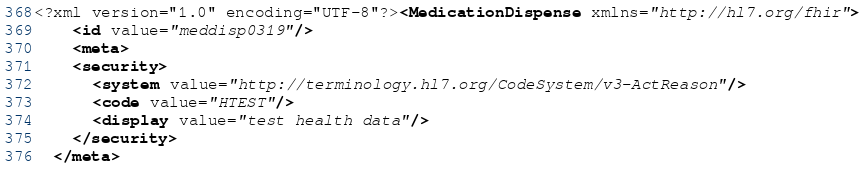Convert code to text. <code><loc_0><loc_0><loc_500><loc_500><_XML_><?xml version="1.0" encoding="UTF-8"?><MedicationDispense xmlns="http://hl7.org/fhir">
    <id value="meddisp0319"/>
    <meta>
    <security>
      <system value="http://terminology.hl7.org/CodeSystem/v3-ActReason"/>
      <code value="HTEST"/>
      <display value="test health data"/>
    </security>
  </meta></code> 